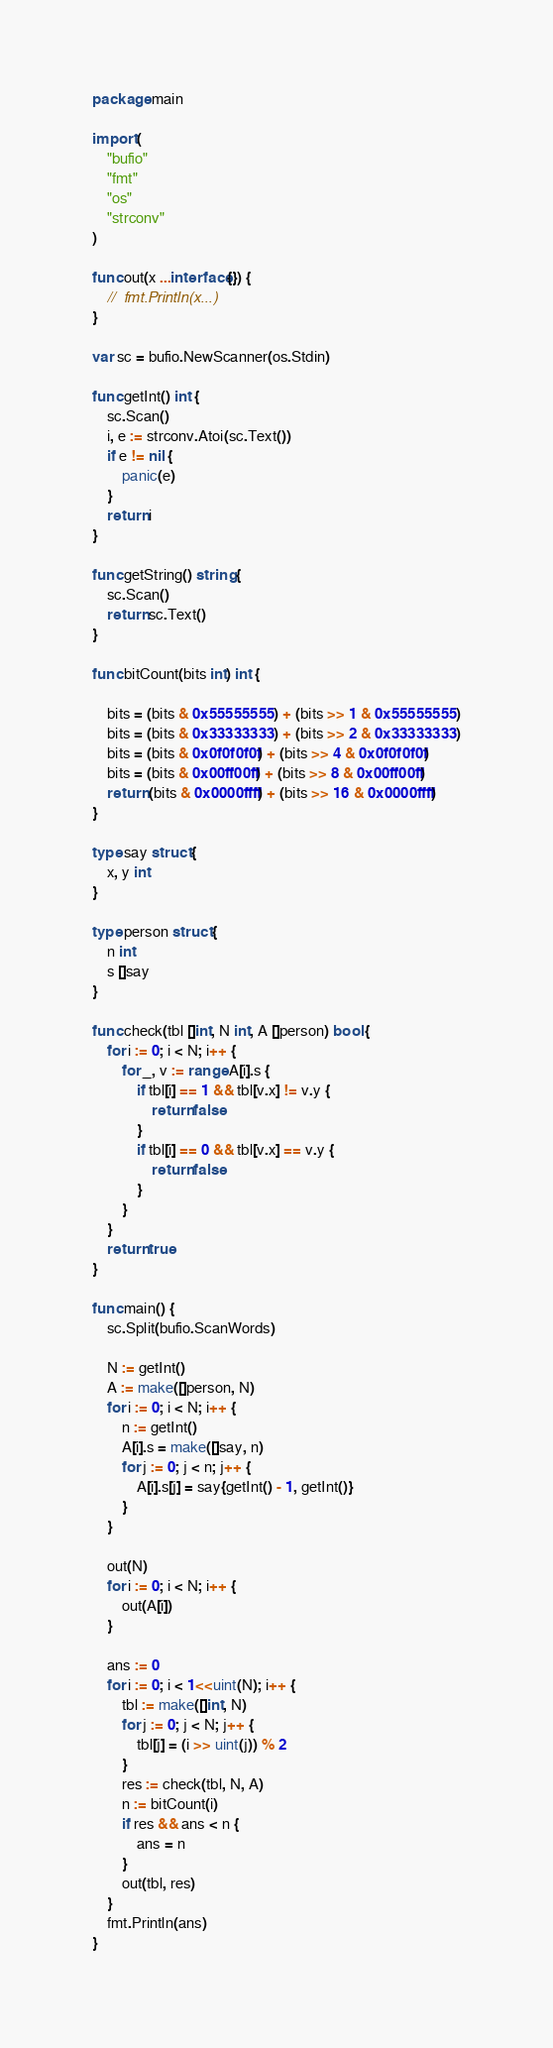<code> <loc_0><loc_0><loc_500><loc_500><_Go_>package main

import (
	"bufio"
	"fmt"
	"os"
	"strconv"
)

func out(x ...interface{}) {
	//	fmt.Println(x...)
}

var sc = bufio.NewScanner(os.Stdin)

func getInt() int {
	sc.Scan()
	i, e := strconv.Atoi(sc.Text())
	if e != nil {
		panic(e)
	}
	return i
}

func getString() string {
	sc.Scan()
	return sc.Text()
}

func bitCount(bits int) int {

	bits = (bits & 0x55555555) + (bits >> 1 & 0x55555555)
	bits = (bits & 0x33333333) + (bits >> 2 & 0x33333333)
	bits = (bits & 0x0f0f0f0f) + (bits >> 4 & 0x0f0f0f0f)
	bits = (bits & 0x00ff00ff) + (bits >> 8 & 0x00ff00ff)
	return (bits & 0x0000ffff) + (bits >> 16 & 0x0000ffff)
}

type say struct {
	x, y int
}

type person struct {
	n int
	s []say
}

func check(tbl []int, N int, A []person) bool {
	for i := 0; i < N; i++ {
		for _, v := range A[i].s {
			if tbl[i] == 1 && tbl[v.x] != v.y {
				return false
			}
			if tbl[i] == 0 && tbl[v.x] == v.y {
				return false
			}
		}
	}
	return true
}

func main() {
	sc.Split(bufio.ScanWords)

	N := getInt()
	A := make([]person, N)
	for i := 0; i < N; i++ {
		n := getInt()
		A[i].s = make([]say, n)
		for j := 0; j < n; j++ {
			A[i].s[j] = say{getInt() - 1, getInt()}
		}
	}

	out(N)
	for i := 0; i < N; i++ {
		out(A[i])
	}

	ans := 0
	for i := 0; i < 1<<uint(N); i++ {
		tbl := make([]int, N)
		for j := 0; j < N; j++ {
			tbl[j] = (i >> uint(j)) % 2
		}
		res := check(tbl, N, A)
		n := bitCount(i)
		if res && ans < n {
			ans = n
		}
		out(tbl, res)
	}
	fmt.Println(ans)
}
</code> 